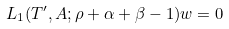Convert formula to latex. <formula><loc_0><loc_0><loc_500><loc_500>L _ { 1 } ( T ^ { \prime } , A ; \rho + \alpha + \beta - 1 ) w = 0</formula> 